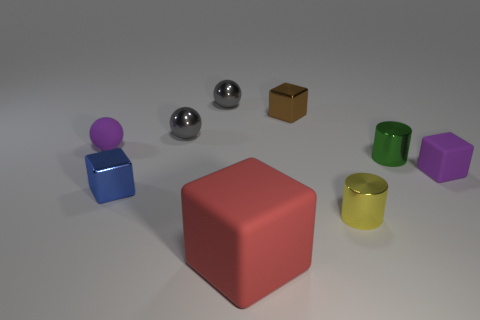Subtract all big blocks. How many blocks are left? 3 Subtract 1 balls. How many balls are left? 2 Subtract all red cubes. How many cubes are left? 3 Add 1 large purple objects. How many objects exist? 10 Subtract all yellow balls. Subtract all gray cylinders. How many balls are left? 3 Subtract all balls. How many objects are left? 6 Add 4 gray objects. How many gray objects are left? 6 Add 6 tiny blue objects. How many tiny blue objects exist? 7 Subtract 0 cyan cylinders. How many objects are left? 9 Subtract all big blocks. Subtract all purple matte balls. How many objects are left? 7 